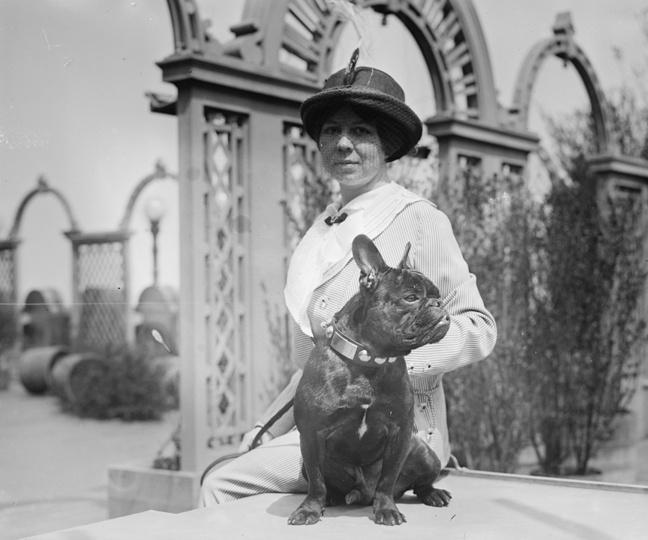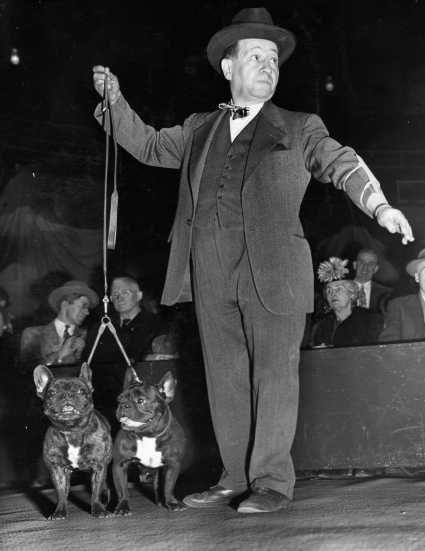The first image is the image on the left, the second image is the image on the right. Given the left and right images, does the statement "A woman is walking multiple dogs on the street." hold true? Answer yes or no. No. The first image is the image on the left, the second image is the image on the right. For the images displayed, is the sentence "The right image shows a person standing to one side of two black pugs with white chest marks and holding onto a leash." factually correct? Answer yes or no. Yes. 